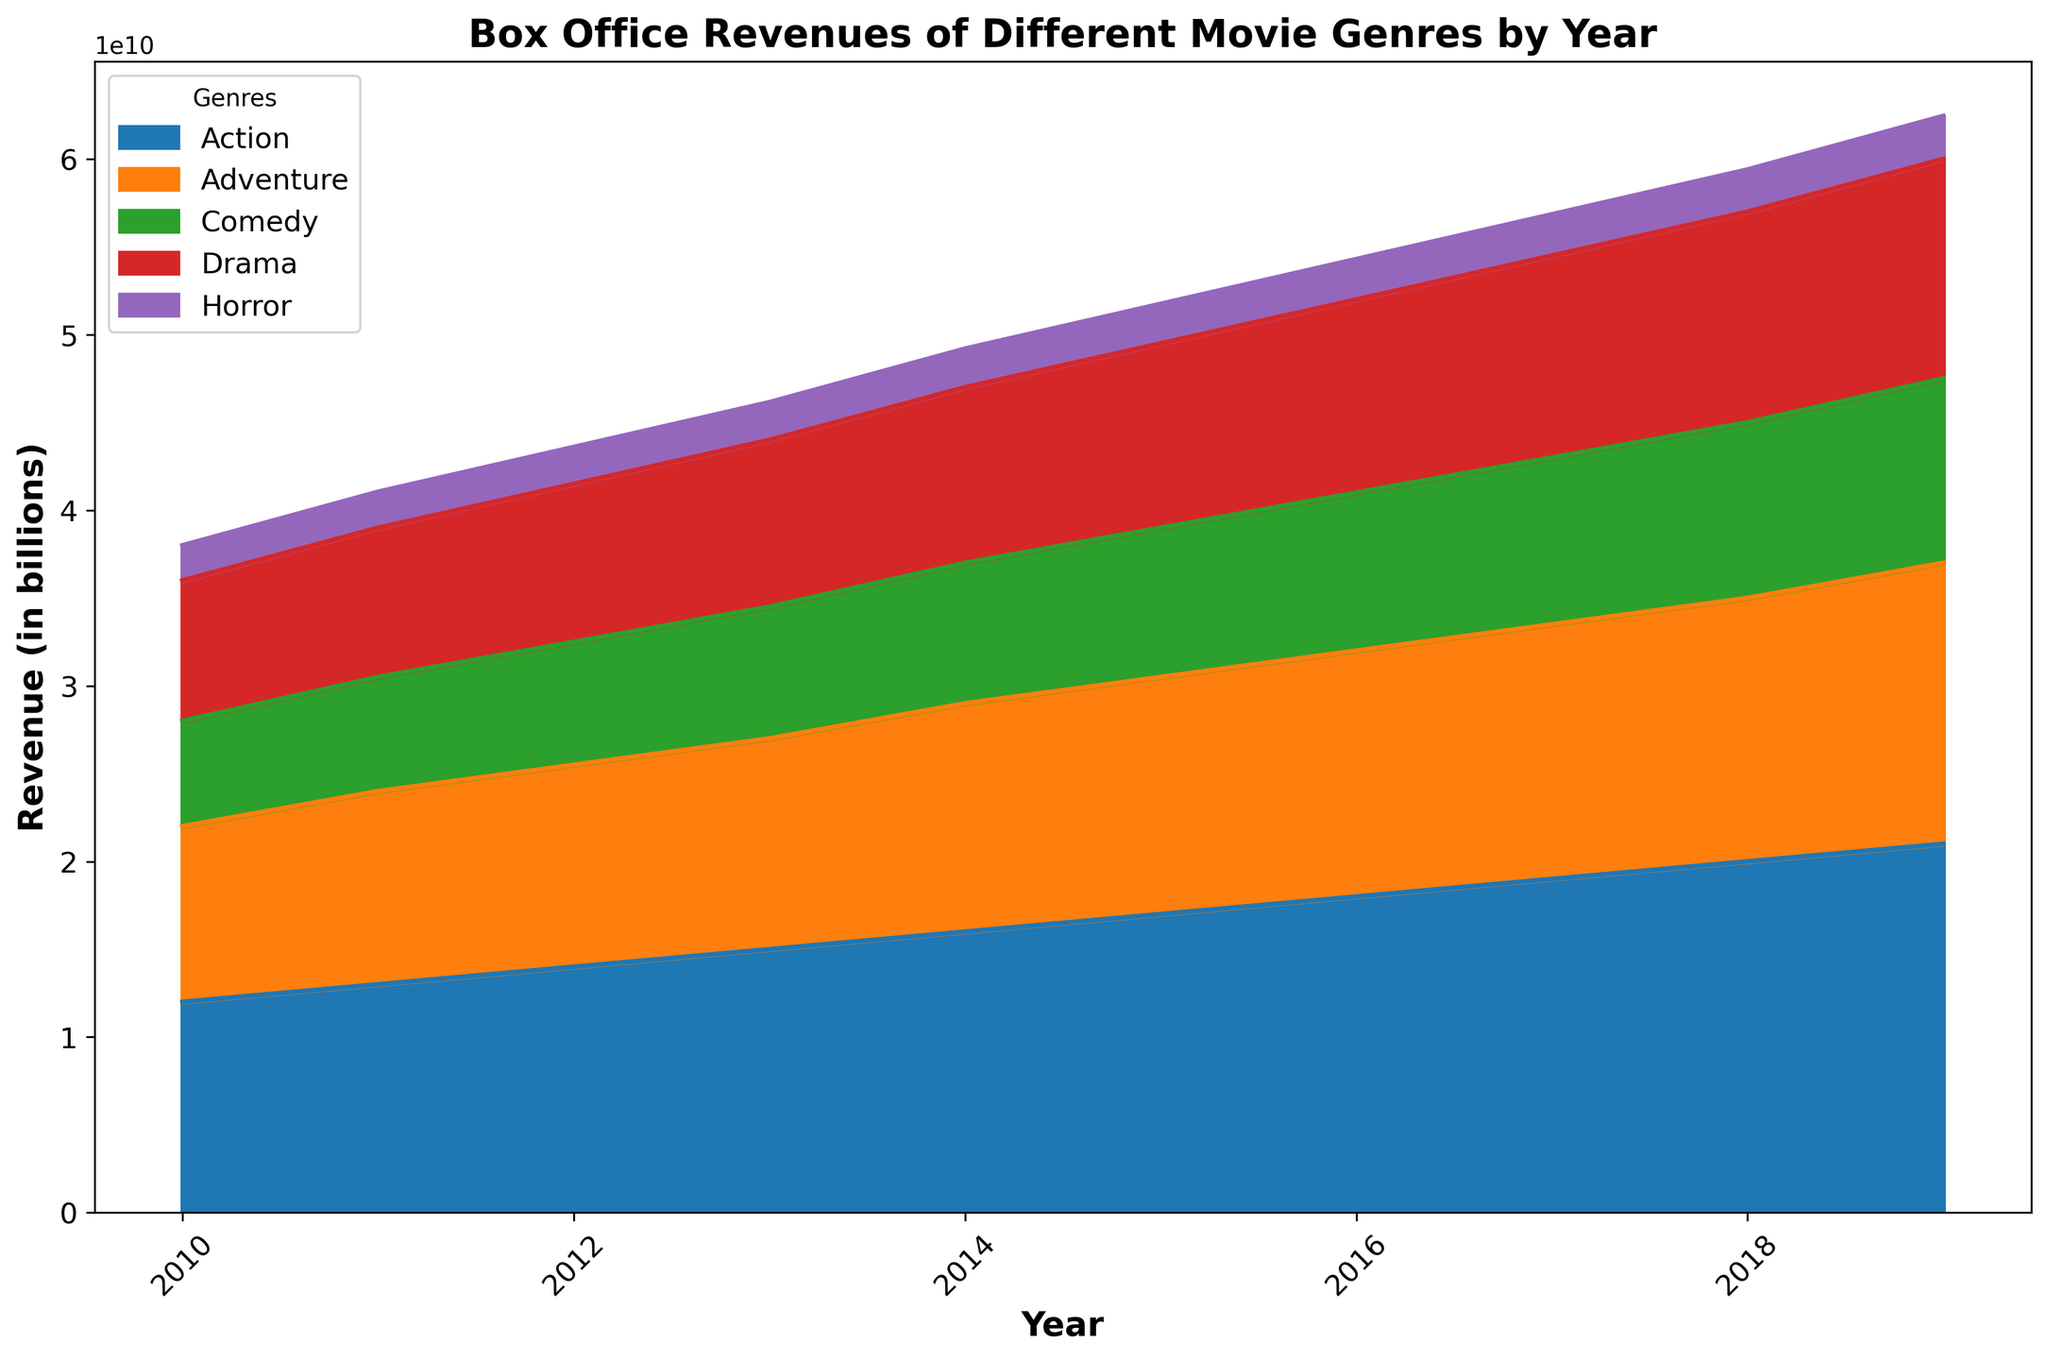What genre had the highest box office revenue in 2019? Look at the 2019 data and identify which genre's area is the largest or highest. The Action genre has the highest peak in 2019.
Answer: Action How did the revenue of Comedy change from 2010 to 2019? Observe the area representing Comedy from 2010 to 2019. The height representing Comedy steadily increased from 6 billion in 2010 to 10.5 billion in 2019.
Answer: Increased Which genre experienced the least change in revenue from 2010 to 2019? Compare the growth rates of each genre's area from 2010 to 2019. Horror had the smallest increase, from 2 billion to 2.45 billion.
Answer: Horror By how much did Adventure revenue grow from 2010 to 2019? Calculate the difference in Adventure revenue between 2010 and 2019. It grew from 10 billion to 16 billion, so the increase is 6 billion.
Answer: 6 billion What is the total revenue of Drama and Horror combined in 2015? Add the revenue of Drama (10.5 billion) and Horror (2.25 billion) for the year 2015.
Answer: 12.75 billion During which year did Action surpass Adventure in revenue? Compare the areas of Action and Adventure year by year until Action’s area becomes greater than Adventure’s. This occurs in 2015, where Action is at 17 billion and Adventure is at 13.5 billion.
Answer: 2015 How does the trend of Drama compare to Comedy from 2010 to 2019? Look at the overall pattern of both Drama and Comedy areas over these years. Both genres show a similar trend of steady growth.
Answer: Steady growth What is the average revenue growth per year for Action from 2010 to 2019? Calculate the total growth (21 billion - 12 billion = 9 billion) and divide it by the number of years (2019 - 2010 = 9). The average annual growth is 9 billion / 9 years.
Answer: 1 billion per year Which genre had the smallest revenue in 2013, and how much was it? Identify the genre with the smallest vertical extent in 2013. Horror had the smallest revenue at 2.15 billion.
Answer: Horror, 2.15 billion 